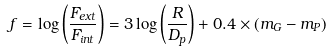<formula> <loc_0><loc_0><loc_500><loc_500>f = \log \left ( \frac { F _ { e x t } } { F _ { i n t } } \right ) = 3 \log \left ( \frac { R } { D _ { p } } \right ) + 0 . 4 \times ( m _ { G } - m _ { P } )</formula> 